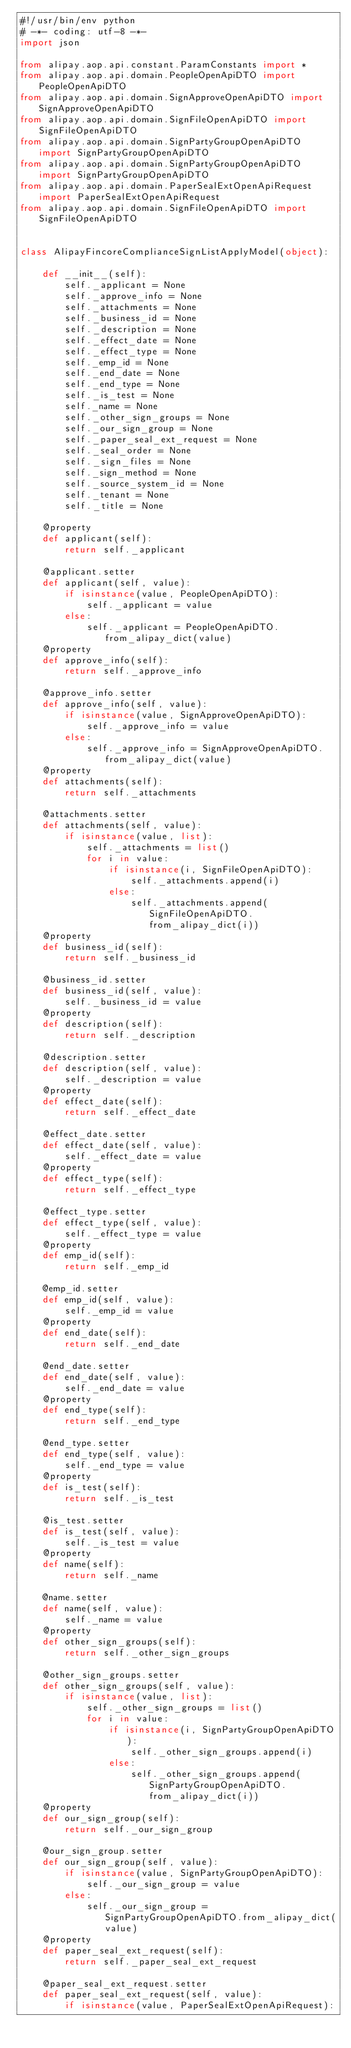<code> <loc_0><loc_0><loc_500><loc_500><_Python_>#!/usr/bin/env python
# -*- coding: utf-8 -*-
import json

from alipay.aop.api.constant.ParamConstants import *
from alipay.aop.api.domain.PeopleOpenApiDTO import PeopleOpenApiDTO
from alipay.aop.api.domain.SignApproveOpenApiDTO import SignApproveOpenApiDTO
from alipay.aop.api.domain.SignFileOpenApiDTO import SignFileOpenApiDTO
from alipay.aop.api.domain.SignPartyGroupOpenApiDTO import SignPartyGroupOpenApiDTO
from alipay.aop.api.domain.SignPartyGroupOpenApiDTO import SignPartyGroupOpenApiDTO
from alipay.aop.api.domain.PaperSealExtOpenApiRequest import PaperSealExtOpenApiRequest
from alipay.aop.api.domain.SignFileOpenApiDTO import SignFileOpenApiDTO


class AlipayFincoreComplianceSignListApplyModel(object):

    def __init__(self):
        self._applicant = None
        self._approve_info = None
        self._attachments = None
        self._business_id = None
        self._description = None
        self._effect_date = None
        self._effect_type = None
        self._emp_id = None
        self._end_date = None
        self._end_type = None
        self._is_test = None
        self._name = None
        self._other_sign_groups = None
        self._our_sign_group = None
        self._paper_seal_ext_request = None
        self._seal_order = None
        self._sign_files = None
        self._sign_method = None
        self._source_system_id = None
        self._tenant = None
        self._title = None

    @property
    def applicant(self):
        return self._applicant

    @applicant.setter
    def applicant(self, value):
        if isinstance(value, PeopleOpenApiDTO):
            self._applicant = value
        else:
            self._applicant = PeopleOpenApiDTO.from_alipay_dict(value)
    @property
    def approve_info(self):
        return self._approve_info

    @approve_info.setter
    def approve_info(self, value):
        if isinstance(value, SignApproveOpenApiDTO):
            self._approve_info = value
        else:
            self._approve_info = SignApproveOpenApiDTO.from_alipay_dict(value)
    @property
    def attachments(self):
        return self._attachments

    @attachments.setter
    def attachments(self, value):
        if isinstance(value, list):
            self._attachments = list()
            for i in value:
                if isinstance(i, SignFileOpenApiDTO):
                    self._attachments.append(i)
                else:
                    self._attachments.append(SignFileOpenApiDTO.from_alipay_dict(i))
    @property
    def business_id(self):
        return self._business_id

    @business_id.setter
    def business_id(self, value):
        self._business_id = value
    @property
    def description(self):
        return self._description

    @description.setter
    def description(self, value):
        self._description = value
    @property
    def effect_date(self):
        return self._effect_date

    @effect_date.setter
    def effect_date(self, value):
        self._effect_date = value
    @property
    def effect_type(self):
        return self._effect_type

    @effect_type.setter
    def effect_type(self, value):
        self._effect_type = value
    @property
    def emp_id(self):
        return self._emp_id

    @emp_id.setter
    def emp_id(self, value):
        self._emp_id = value
    @property
    def end_date(self):
        return self._end_date

    @end_date.setter
    def end_date(self, value):
        self._end_date = value
    @property
    def end_type(self):
        return self._end_type

    @end_type.setter
    def end_type(self, value):
        self._end_type = value
    @property
    def is_test(self):
        return self._is_test

    @is_test.setter
    def is_test(self, value):
        self._is_test = value
    @property
    def name(self):
        return self._name

    @name.setter
    def name(self, value):
        self._name = value
    @property
    def other_sign_groups(self):
        return self._other_sign_groups

    @other_sign_groups.setter
    def other_sign_groups(self, value):
        if isinstance(value, list):
            self._other_sign_groups = list()
            for i in value:
                if isinstance(i, SignPartyGroupOpenApiDTO):
                    self._other_sign_groups.append(i)
                else:
                    self._other_sign_groups.append(SignPartyGroupOpenApiDTO.from_alipay_dict(i))
    @property
    def our_sign_group(self):
        return self._our_sign_group

    @our_sign_group.setter
    def our_sign_group(self, value):
        if isinstance(value, SignPartyGroupOpenApiDTO):
            self._our_sign_group = value
        else:
            self._our_sign_group = SignPartyGroupOpenApiDTO.from_alipay_dict(value)
    @property
    def paper_seal_ext_request(self):
        return self._paper_seal_ext_request

    @paper_seal_ext_request.setter
    def paper_seal_ext_request(self, value):
        if isinstance(value, PaperSealExtOpenApiRequest):</code> 